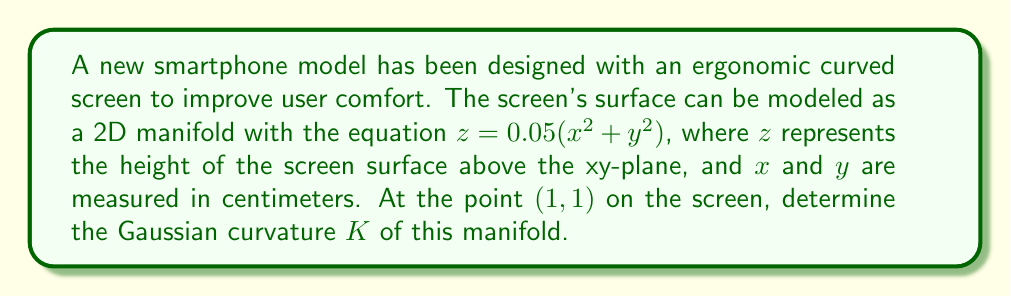Could you help me with this problem? To determine the Gaussian curvature of the 2D manifold representing the smartphone screen, we'll follow these steps:

1. The surface is given by the equation $z = f(x,y) = 0.05(x^2 + y^2)$.

2. To calculate the Gaussian curvature, we need to find the first and second fundamental forms. For a surface given by $z = f(x,y)$, the Gaussian curvature is:

   $$K = \frac{f_{xx}f_{yy} - f_{xy}^2}{(1 + f_x^2 + f_y^2)^2}$$

   where $f_x, f_y$ are first partial derivatives, and $f_{xx}, f_{yy}, f_{xy}$ are second partial derivatives.

3. Let's calculate these derivatives:
   
   $f_x = 0.1x$
   $f_y = 0.1y$
   $f_{xx} = 0.1$
   $f_{yy} = 0.1$
   $f_{xy} = 0$

4. Now, let's substitute these values into the Gaussian curvature formula at the point (1, 1):

   $$K = \frac{(0.1)(0.1) - 0^2}{(1 + (0.1)^2 + (0.1)^2)^2}$$

5. Simplify:
   
   $$K = \frac{0.01}{(1 + 0.02)^2} = \frac{0.01}{1.0404} \approx 0.00961$$

The Gaussian curvature at the point (1, 1) on the screen is approximately 0.00961 cm^(-2).
Answer: The Gaussian curvature $K$ of the smartphone screen at the point (1, 1) is approximately 0.00961 cm^(-2). 